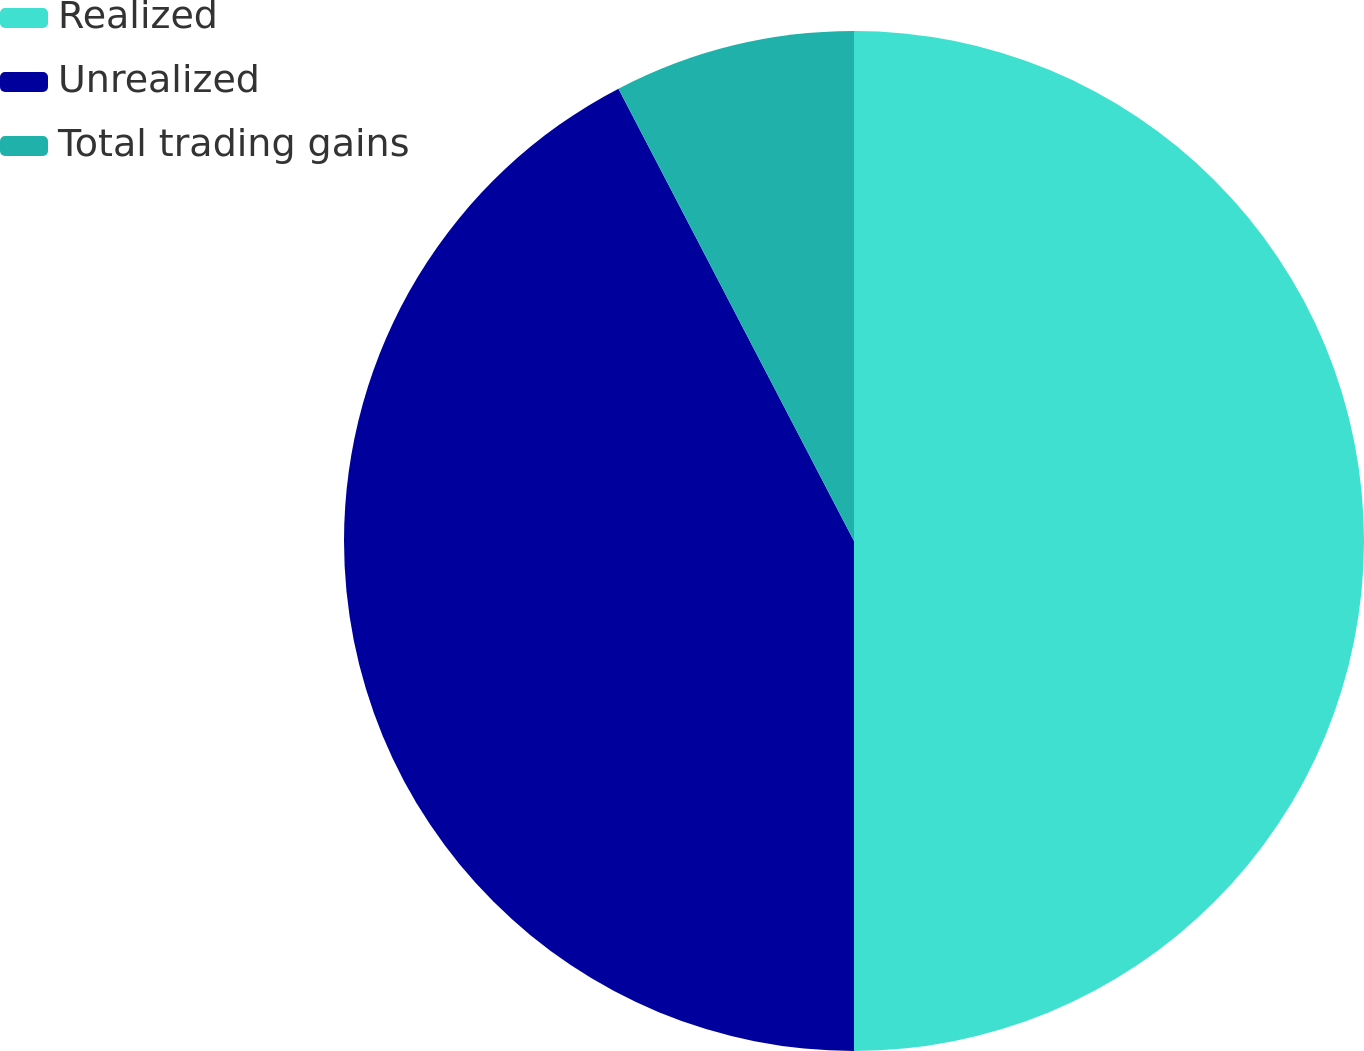Convert chart. <chart><loc_0><loc_0><loc_500><loc_500><pie_chart><fcel>Realized<fcel>Unrealized<fcel>Total trading gains<nl><fcel>50.0%<fcel>42.36%<fcel>7.64%<nl></chart> 